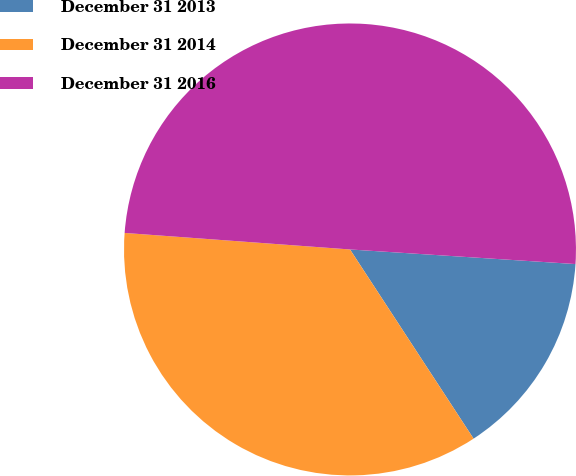<chart> <loc_0><loc_0><loc_500><loc_500><pie_chart><fcel>December 31 2013<fcel>December 31 2014<fcel>December 31 2016<nl><fcel>14.76%<fcel>35.37%<fcel>49.86%<nl></chart> 